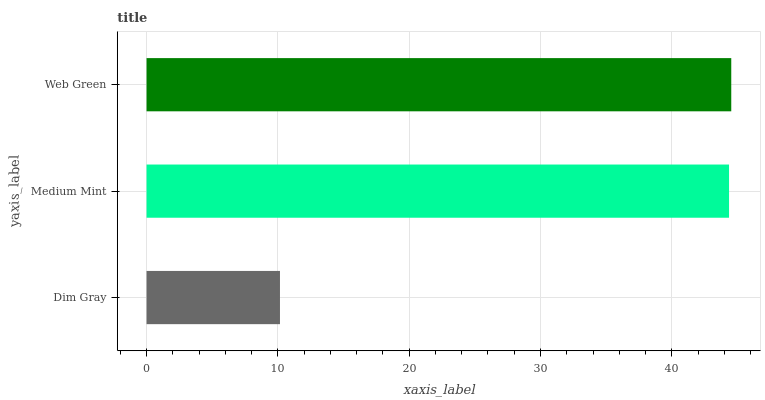Is Dim Gray the minimum?
Answer yes or no. Yes. Is Web Green the maximum?
Answer yes or no. Yes. Is Medium Mint the minimum?
Answer yes or no. No. Is Medium Mint the maximum?
Answer yes or no. No. Is Medium Mint greater than Dim Gray?
Answer yes or no. Yes. Is Dim Gray less than Medium Mint?
Answer yes or no. Yes. Is Dim Gray greater than Medium Mint?
Answer yes or no. No. Is Medium Mint less than Dim Gray?
Answer yes or no. No. Is Medium Mint the high median?
Answer yes or no. Yes. Is Medium Mint the low median?
Answer yes or no. Yes. Is Dim Gray the high median?
Answer yes or no. No. Is Dim Gray the low median?
Answer yes or no. No. 